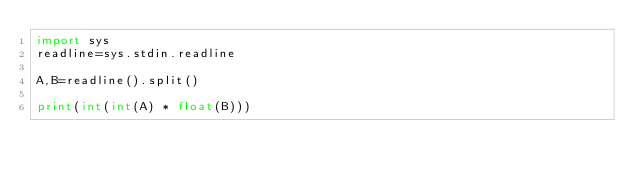Convert code to text. <code><loc_0><loc_0><loc_500><loc_500><_Python_>import sys
readline=sys.stdin.readline
 
A,B=readline().split()

print(int(int(A) * float(B)))
</code> 